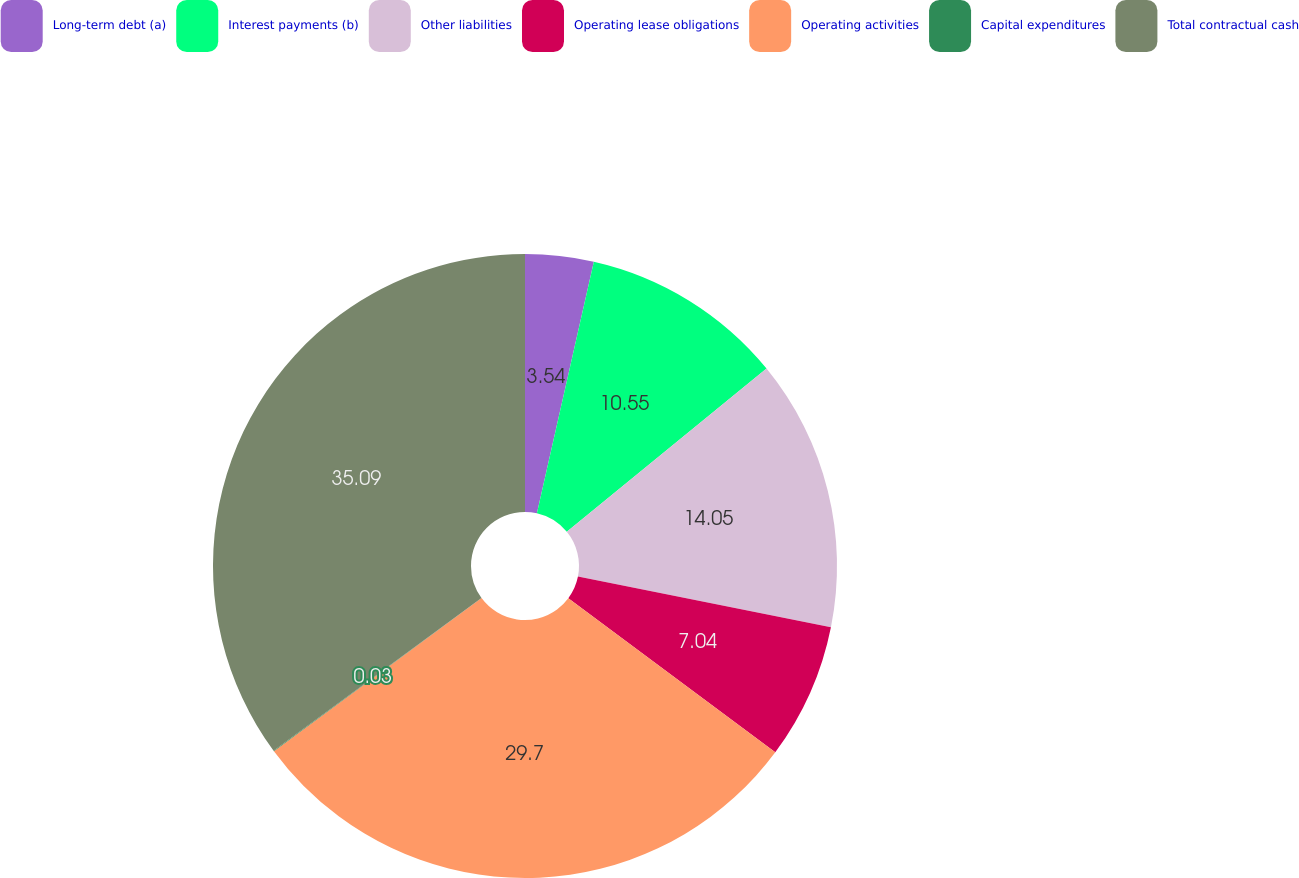Convert chart to OTSL. <chart><loc_0><loc_0><loc_500><loc_500><pie_chart><fcel>Long-term debt (a)<fcel>Interest payments (b)<fcel>Other liabilities<fcel>Operating lease obligations<fcel>Operating activities<fcel>Capital expenditures<fcel>Total contractual cash<nl><fcel>3.54%<fcel>10.55%<fcel>14.05%<fcel>7.04%<fcel>29.7%<fcel>0.03%<fcel>35.08%<nl></chart> 